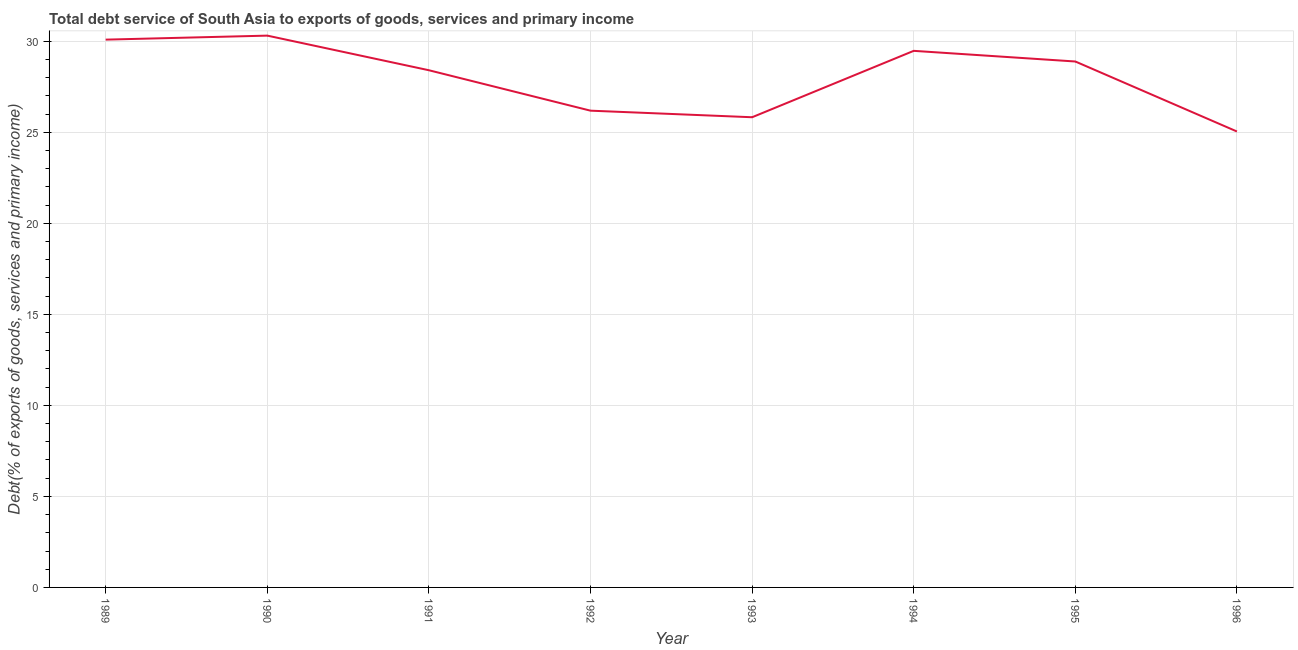What is the total debt service in 1995?
Provide a short and direct response. 28.88. Across all years, what is the maximum total debt service?
Give a very brief answer. 30.31. Across all years, what is the minimum total debt service?
Offer a terse response. 25.04. In which year was the total debt service maximum?
Provide a succinct answer. 1990. In which year was the total debt service minimum?
Provide a short and direct response. 1996. What is the sum of the total debt service?
Keep it short and to the point. 224.2. What is the difference between the total debt service in 1989 and 1996?
Your response must be concise. 5.05. What is the average total debt service per year?
Offer a very short reply. 28.02. What is the median total debt service?
Offer a very short reply. 28.64. Do a majority of the years between 1996 and 1989 (inclusive) have total debt service greater than 28 %?
Keep it short and to the point. Yes. What is the ratio of the total debt service in 1989 to that in 1994?
Your answer should be compact. 1.02. Is the total debt service in 1990 less than that in 1993?
Your response must be concise. No. Is the difference between the total debt service in 1992 and 1995 greater than the difference between any two years?
Keep it short and to the point. No. What is the difference between the highest and the second highest total debt service?
Offer a terse response. 0.22. What is the difference between the highest and the lowest total debt service?
Your answer should be very brief. 5.27. In how many years, is the total debt service greater than the average total debt service taken over all years?
Your response must be concise. 5. Does the total debt service monotonically increase over the years?
Your response must be concise. No. How many years are there in the graph?
Your response must be concise. 8. What is the title of the graph?
Give a very brief answer. Total debt service of South Asia to exports of goods, services and primary income. What is the label or title of the Y-axis?
Keep it short and to the point. Debt(% of exports of goods, services and primary income). What is the Debt(% of exports of goods, services and primary income) of 1989?
Offer a very short reply. 30.09. What is the Debt(% of exports of goods, services and primary income) in 1990?
Your answer should be very brief. 30.31. What is the Debt(% of exports of goods, services and primary income) in 1991?
Your answer should be compact. 28.4. What is the Debt(% of exports of goods, services and primary income) in 1992?
Provide a succinct answer. 26.18. What is the Debt(% of exports of goods, services and primary income) of 1993?
Your answer should be compact. 25.82. What is the Debt(% of exports of goods, services and primary income) in 1994?
Keep it short and to the point. 29.47. What is the Debt(% of exports of goods, services and primary income) in 1995?
Provide a succinct answer. 28.88. What is the Debt(% of exports of goods, services and primary income) of 1996?
Ensure brevity in your answer.  25.04. What is the difference between the Debt(% of exports of goods, services and primary income) in 1989 and 1990?
Your response must be concise. -0.22. What is the difference between the Debt(% of exports of goods, services and primary income) in 1989 and 1991?
Give a very brief answer. 1.68. What is the difference between the Debt(% of exports of goods, services and primary income) in 1989 and 1992?
Your answer should be compact. 3.9. What is the difference between the Debt(% of exports of goods, services and primary income) in 1989 and 1993?
Ensure brevity in your answer.  4.26. What is the difference between the Debt(% of exports of goods, services and primary income) in 1989 and 1994?
Make the answer very short. 0.62. What is the difference between the Debt(% of exports of goods, services and primary income) in 1989 and 1995?
Keep it short and to the point. 1.2. What is the difference between the Debt(% of exports of goods, services and primary income) in 1989 and 1996?
Your response must be concise. 5.05. What is the difference between the Debt(% of exports of goods, services and primary income) in 1990 and 1991?
Give a very brief answer. 1.9. What is the difference between the Debt(% of exports of goods, services and primary income) in 1990 and 1992?
Provide a succinct answer. 4.12. What is the difference between the Debt(% of exports of goods, services and primary income) in 1990 and 1993?
Your answer should be very brief. 4.48. What is the difference between the Debt(% of exports of goods, services and primary income) in 1990 and 1994?
Offer a very short reply. 0.84. What is the difference between the Debt(% of exports of goods, services and primary income) in 1990 and 1995?
Make the answer very short. 1.42. What is the difference between the Debt(% of exports of goods, services and primary income) in 1990 and 1996?
Your answer should be very brief. 5.27. What is the difference between the Debt(% of exports of goods, services and primary income) in 1991 and 1992?
Ensure brevity in your answer.  2.22. What is the difference between the Debt(% of exports of goods, services and primary income) in 1991 and 1993?
Provide a short and direct response. 2.58. What is the difference between the Debt(% of exports of goods, services and primary income) in 1991 and 1994?
Keep it short and to the point. -1.07. What is the difference between the Debt(% of exports of goods, services and primary income) in 1991 and 1995?
Make the answer very short. -0.48. What is the difference between the Debt(% of exports of goods, services and primary income) in 1991 and 1996?
Offer a terse response. 3.36. What is the difference between the Debt(% of exports of goods, services and primary income) in 1992 and 1993?
Your answer should be very brief. 0.36. What is the difference between the Debt(% of exports of goods, services and primary income) in 1992 and 1994?
Offer a very short reply. -3.29. What is the difference between the Debt(% of exports of goods, services and primary income) in 1992 and 1995?
Your answer should be very brief. -2.7. What is the difference between the Debt(% of exports of goods, services and primary income) in 1992 and 1996?
Give a very brief answer. 1.14. What is the difference between the Debt(% of exports of goods, services and primary income) in 1993 and 1994?
Your answer should be compact. -3.65. What is the difference between the Debt(% of exports of goods, services and primary income) in 1993 and 1995?
Keep it short and to the point. -3.06. What is the difference between the Debt(% of exports of goods, services and primary income) in 1993 and 1996?
Your answer should be very brief. 0.78. What is the difference between the Debt(% of exports of goods, services and primary income) in 1994 and 1995?
Your response must be concise. 0.58. What is the difference between the Debt(% of exports of goods, services and primary income) in 1994 and 1996?
Make the answer very short. 4.43. What is the difference between the Debt(% of exports of goods, services and primary income) in 1995 and 1996?
Provide a short and direct response. 3.84. What is the ratio of the Debt(% of exports of goods, services and primary income) in 1989 to that in 1990?
Your answer should be compact. 0.99. What is the ratio of the Debt(% of exports of goods, services and primary income) in 1989 to that in 1991?
Provide a succinct answer. 1.06. What is the ratio of the Debt(% of exports of goods, services and primary income) in 1989 to that in 1992?
Provide a short and direct response. 1.15. What is the ratio of the Debt(% of exports of goods, services and primary income) in 1989 to that in 1993?
Give a very brief answer. 1.17. What is the ratio of the Debt(% of exports of goods, services and primary income) in 1989 to that in 1995?
Make the answer very short. 1.04. What is the ratio of the Debt(% of exports of goods, services and primary income) in 1989 to that in 1996?
Your answer should be compact. 1.2. What is the ratio of the Debt(% of exports of goods, services and primary income) in 1990 to that in 1991?
Give a very brief answer. 1.07. What is the ratio of the Debt(% of exports of goods, services and primary income) in 1990 to that in 1992?
Provide a succinct answer. 1.16. What is the ratio of the Debt(% of exports of goods, services and primary income) in 1990 to that in 1993?
Give a very brief answer. 1.17. What is the ratio of the Debt(% of exports of goods, services and primary income) in 1990 to that in 1994?
Keep it short and to the point. 1.03. What is the ratio of the Debt(% of exports of goods, services and primary income) in 1990 to that in 1995?
Keep it short and to the point. 1.05. What is the ratio of the Debt(% of exports of goods, services and primary income) in 1990 to that in 1996?
Provide a succinct answer. 1.21. What is the ratio of the Debt(% of exports of goods, services and primary income) in 1991 to that in 1992?
Keep it short and to the point. 1.08. What is the ratio of the Debt(% of exports of goods, services and primary income) in 1991 to that in 1994?
Your answer should be compact. 0.96. What is the ratio of the Debt(% of exports of goods, services and primary income) in 1991 to that in 1995?
Give a very brief answer. 0.98. What is the ratio of the Debt(% of exports of goods, services and primary income) in 1991 to that in 1996?
Your answer should be compact. 1.13. What is the ratio of the Debt(% of exports of goods, services and primary income) in 1992 to that in 1994?
Give a very brief answer. 0.89. What is the ratio of the Debt(% of exports of goods, services and primary income) in 1992 to that in 1995?
Offer a terse response. 0.91. What is the ratio of the Debt(% of exports of goods, services and primary income) in 1992 to that in 1996?
Offer a very short reply. 1.05. What is the ratio of the Debt(% of exports of goods, services and primary income) in 1993 to that in 1994?
Your answer should be very brief. 0.88. What is the ratio of the Debt(% of exports of goods, services and primary income) in 1993 to that in 1995?
Ensure brevity in your answer.  0.89. What is the ratio of the Debt(% of exports of goods, services and primary income) in 1993 to that in 1996?
Offer a terse response. 1.03. What is the ratio of the Debt(% of exports of goods, services and primary income) in 1994 to that in 1996?
Make the answer very short. 1.18. What is the ratio of the Debt(% of exports of goods, services and primary income) in 1995 to that in 1996?
Make the answer very short. 1.15. 